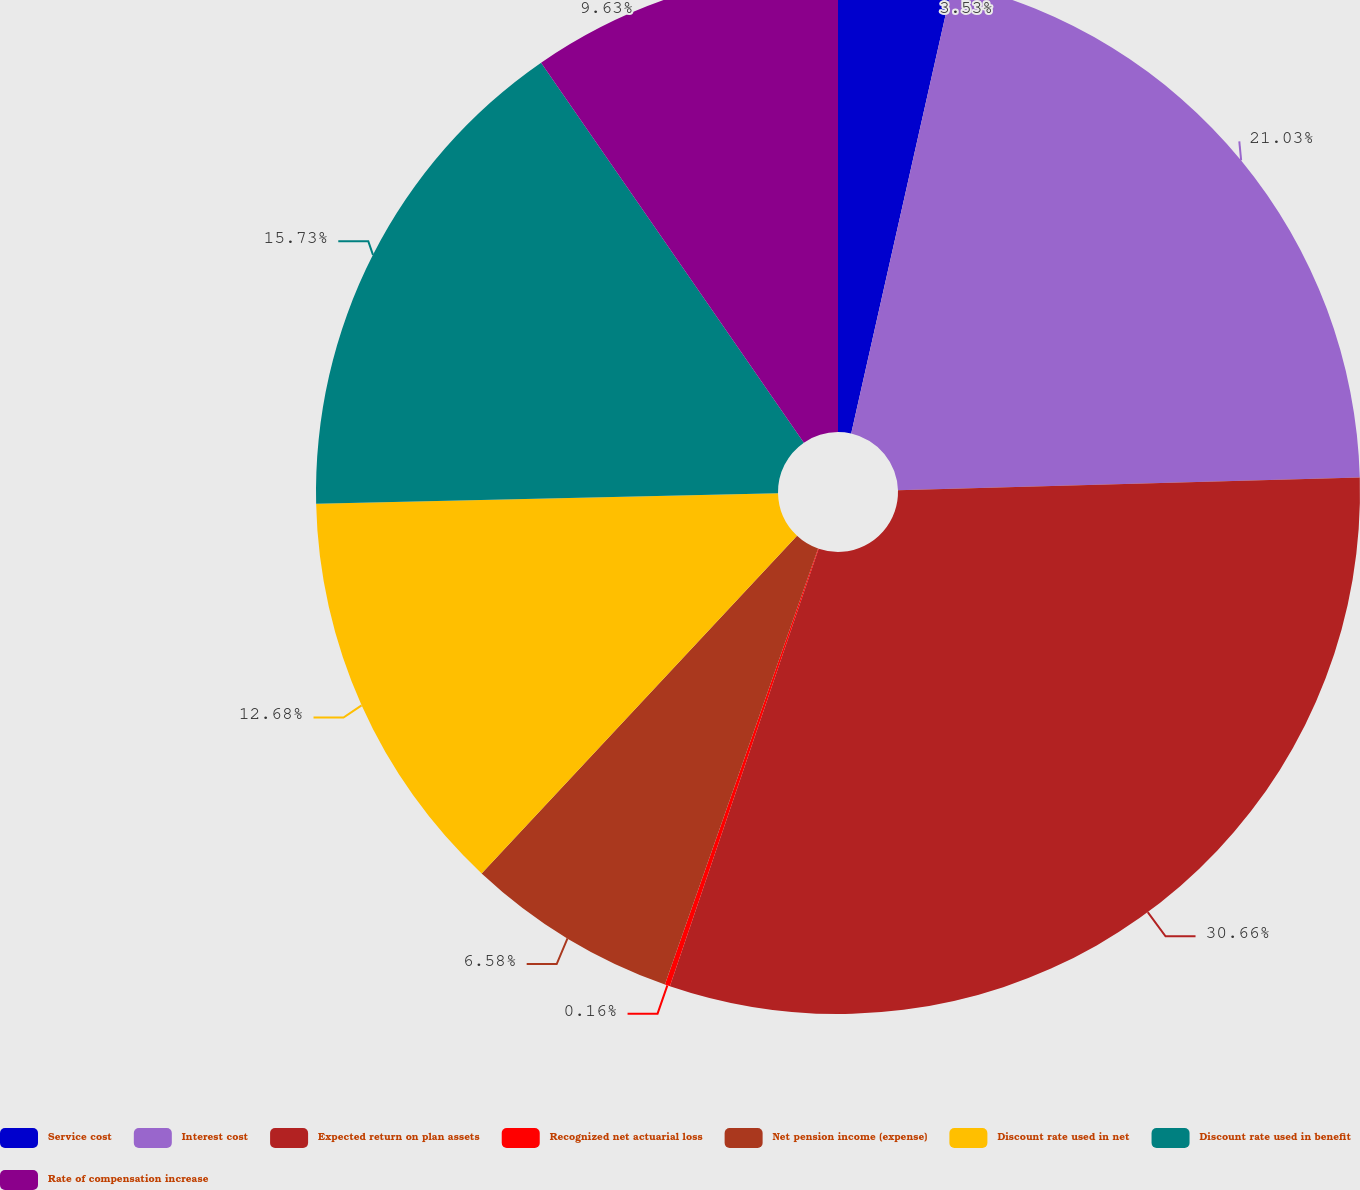Convert chart to OTSL. <chart><loc_0><loc_0><loc_500><loc_500><pie_chart><fcel>Service cost<fcel>Interest cost<fcel>Expected return on plan assets<fcel>Recognized net actuarial loss<fcel>Net pension income (expense)<fcel>Discount rate used in net<fcel>Discount rate used in benefit<fcel>Rate of compensation increase<nl><fcel>3.53%<fcel>21.03%<fcel>30.66%<fcel>0.16%<fcel>6.58%<fcel>12.68%<fcel>15.73%<fcel>9.63%<nl></chart> 